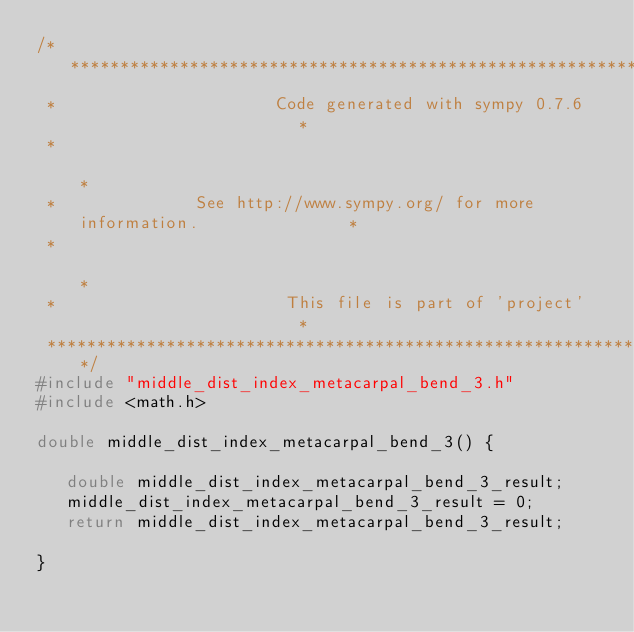<code> <loc_0><loc_0><loc_500><loc_500><_C_>/******************************************************************************
 *                      Code generated with sympy 0.7.6                       *
 *                                                                            *
 *              See http://www.sympy.org/ for more information.               *
 *                                                                            *
 *                       This file is part of 'project'                       *
 ******************************************************************************/
#include "middle_dist_index_metacarpal_bend_3.h"
#include <math.h>

double middle_dist_index_metacarpal_bend_3() {

   double middle_dist_index_metacarpal_bend_3_result;
   middle_dist_index_metacarpal_bend_3_result = 0;
   return middle_dist_index_metacarpal_bend_3_result;

}
</code> 